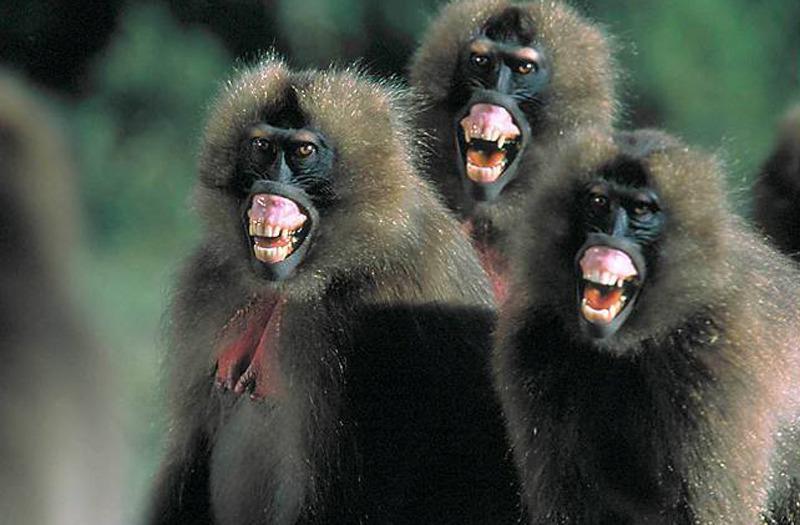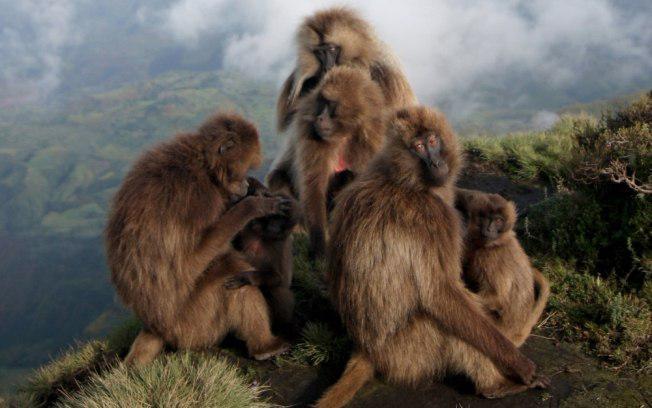The first image is the image on the left, the second image is the image on the right. For the images displayed, is the sentence "There are exactly two animals visible in the right image." factually correct? Answer yes or no. No. The first image is the image on the left, the second image is the image on the right. For the images shown, is this caption "No image contains more than three monkeys, and one image shows a monkey with both paws grooming the fur of the monkey next to it." true? Answer yes or no. No. 